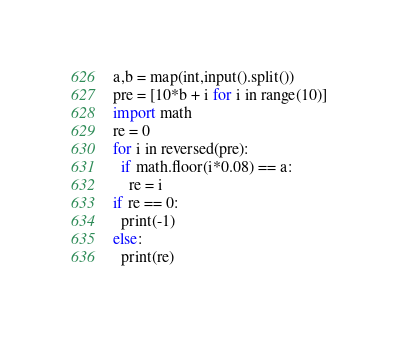<code> <loc_0><loc_0><loc_500><loc_500><_Python_>a,b = map(int,input().split())
pre = [10*b + i for i in range(10)]
import math
re = 0
for i in reversed(pre):
  if math.floor(i*0.08) == a:
    re = i
if re == 0:
  print(-1)
else:
  print(re)</code> 